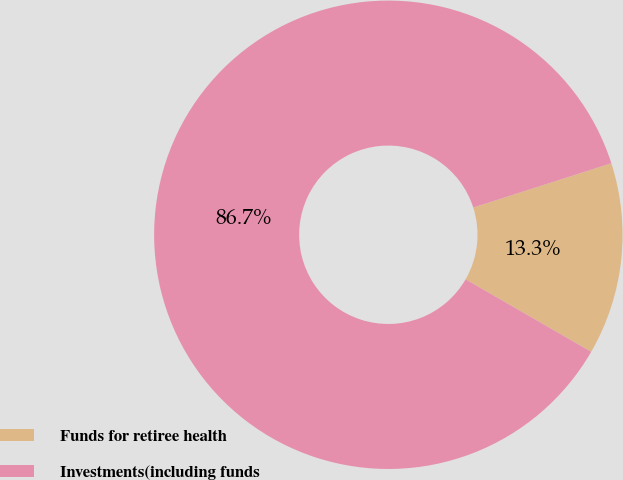Convert chart to OTSL. <chart><loc_0><loc_0><loc_500><loc_500><pie_chart><fcel>Funds for retiree health<fcel>Investments(including funds<nl><fcel>13.27%<fcel>86.73%<nl></chart> 